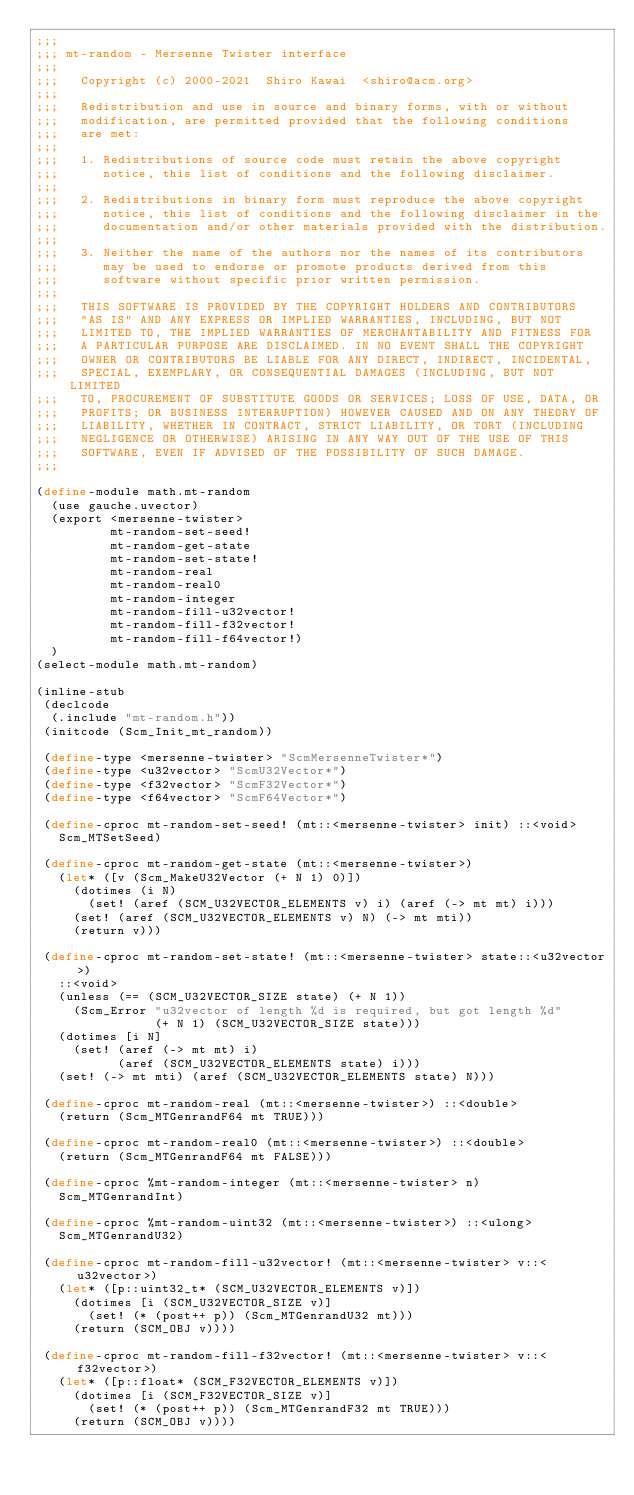<code> <loc_0><loc_0><loc_500><loc_500><_Scheme_>;;;
;;; mt-random - Mersenne Twister interface
;;;
;;;   Copyright (c) 2000-2021  Shiro Kawai  <shiro@acm.org>
;;;
;;;   Redistribution and use in source and binary forms, with or without
;;;   modification, are permitted provided that the following conditions
;;;   are met:
;;;
;;;   1. Redistributions of source code must retain the above copyright
;;;      notice, this list of conditions and the following disclaimer.
;;;
;;;   2. Redistributions in binary form must reproduce the above copyright
;;;      notice, this list of conditions and the following disclaimer in the
;;;      documentation and/or other materials provided with the distribution.
;;;
;;;   3. Neither the name of the authors nor the names of its contributors
;;;      may be used to endorse or promote products derived from this
;;;      software without specific prior written permission.
;;;
;;;   THIS SOFTWARE IS PROVIDED BY THE COPYRIGHT HOLDERS AND CONTRIBUTORS
;;;   "AS IS" AND ANY EXPRESS OR IMPLIED WARRANTIES, INCLUDING, BUT NOT
;;;   LIMITED TO, THE IMPLIED WARRANTIES OF MERCHANTABILITY AND FITNESS FOR
;;;   A PARTICULAR PURPOSE ARE DISCLAIMED. IN NO EVENT SHALL THE COPYRIGHT
;;;   OWNER OR CONTRIBUTORS BE LIABLE FOR ANY DIRECT, INDIRECT, INCIDENTAL,
;;;   SPECIAL, EXEMPLARY, OR CONSEQUENTIAL DAMAGES (INCLUDING, BUT NOT LIMITED
;;;   TO, PROCUREMENT OF SUBSTITUTE GOODS OR SERVICES; LOSS OF USE, DATA, OR
;;;   PROFITS; OR BUSINESS INTERRUPTION) HOWEVER CAUSED AND ON ANY THEORY OF
;;;   LIABILITY, WHETHER IN CONTRACT, STRICT LIABILITY, OR TORT (INCLUDING
;;;   NEGLIGENCE OR OTHERWISE) ARISING IN ANY WAY OUT OF THE USE OF THIS
;;;   SOFTWARE, EVEN IF ADVISED OF THE POSSIBILITY OF SUCH DAMAGE.
;;;

(define-module math.mt-random
  (use gauche.uvector)
  (export <mersenne-twister>
          mt-random-set-seed!
          mt-random-get-state
          mt-random-set-state!
          mt-random-real
          mt-random-real0
          mt-random-integer
          mt-random-fill-u32vector!
          mt-random-fill-f32vector!
          mt-random-fill-f64vector!)
  )
(select-module math.mt-random)

(inline-stub
 (declcode
  (.include "mt-random.h"))
 (initcode (Scm_Init_mt_random))

 (define-type <mersenne-twister> "ScmMersenneTwister*")
 (define-type <u32vector> "ScmU32Vector*")
 (define-type <f32vector> "ScmF32Vector*")
 (define-type <f64vector> "ScmF64Vector*")

 (define-cproc mt-random-set-seed! (mt::<mersenne-twister> init) ::<void>
   Scm_MTSetSeed)

 (define-cproc mt-random-get-state (mt::<mersenne-twister>)
   (let* ([v (Scm_MakeU32Vector (+ N 1) 0)])
     (dotimes (i N)
       (set! (aref (SCM_U32VECTOR_ELEMENTS v) i) (aref (-> mt mt) i)))
     (set! (aref (SCM_U32VECTOR_ELEMENTS v) N) (-> mt mti))
     (return v)))

 (define-cproc mt-random-set-state! (mt::<mersenne-twister> state::<u32vector>)
   ::<void>
   (unless (== (SCM_U32VECTOR_SIZE state) (+ N 1))
     (Scm_Error "u32vector of length %d is required, but got length %d"
                (+ N 1) (SCM_U32VECTOR_SIZE state)))
   (dotimes [i N]
     (set! (aref (-> mt mt) i)
           (aref (SCM_U32VECTOR_ELEMENTS state) i)))
   (set! (-> mt mti) (aref (SCM_U32VECTOR_ELEMENTS state) N)))

 (define-cproc mt-random-real (mt::<mersenne-twister>) ::<double>
   (return (Scm_MTGenrandF64 mt TRUE)))

 (define-cproc mt-random-real0 (mt::<mersenne-twister>) ::<double>
   (return (Scm_MTGenrandF64 mt FALSE)))

 (define-cproc %mt-random-integer (mt::<mersenne-twister> n)
   Scm_MTGenrandInt)

 (define-cproc %mt-random-uint32 (mt::<mersenne-twister>) ::<ulong>
   Scm_MTGenrandU32)

 (define-cproc mt-random-fill-u32vector! (mt::<mersenne-twister> v::<u32vector>)
   (let* ([p::uint32_t* (SCM_U32VECTOR_ELEMENTS v)])
     (dotimes [i (SCM_U32VECTOR_SIZE v)]
       (set! (* (post++ p)) (Scm_MTGenrandU32 mt)))
     (return (SCM_OBJ v))))

 (define-cproc mt-random-fill-f32vector! (mt::<mersenne-twister> v::<f32vector>)
   (let* ([p::float* (SCM_F32VECTOR_ELEMENTS v)])
     (dotimes [i (SCM_F32VECTOR_SIZE v)]
       (set! (* (post++ p)) (Scm_MTGenrandF32 mt TRUE)))
     (return (SCM_OBJ v))))
</code> 